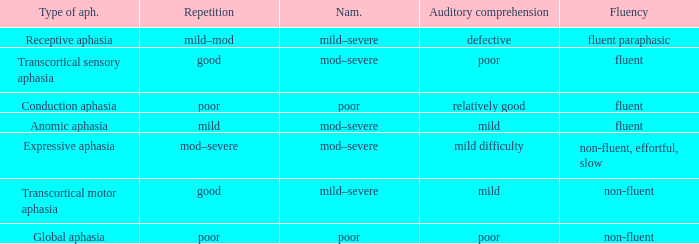Name the fluency for transcortical sensory aphasia Fluent. 